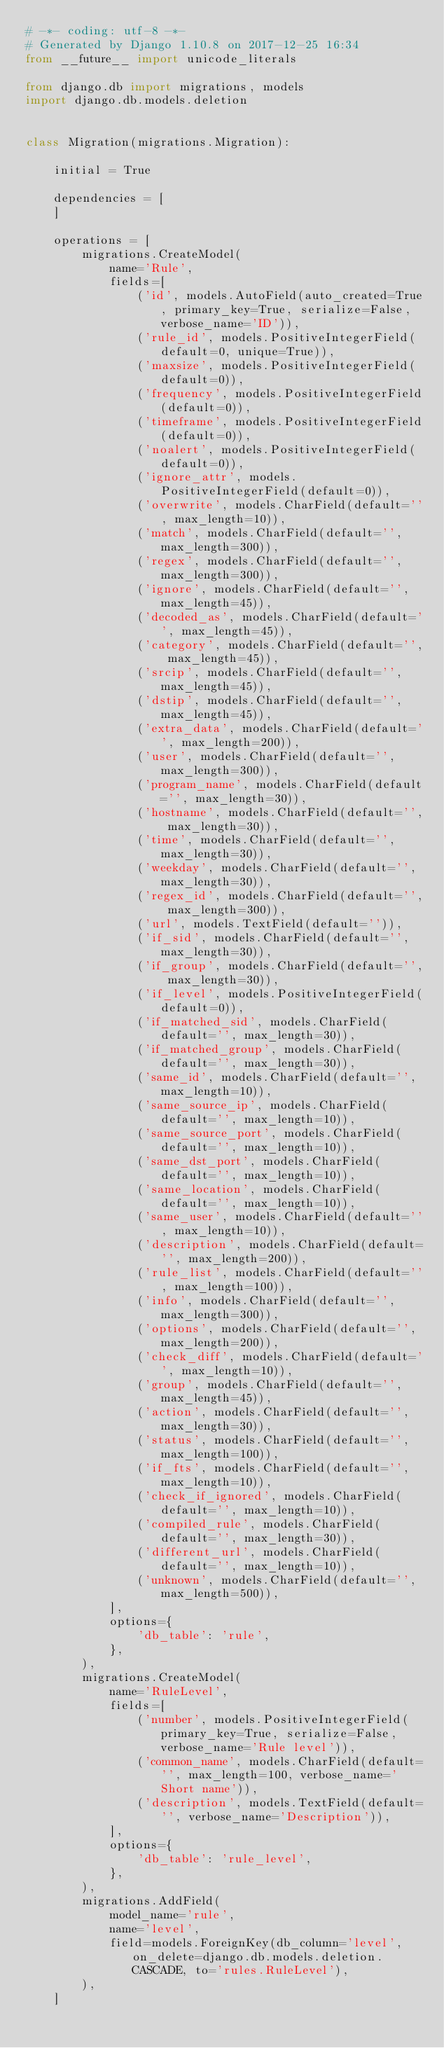Convert code to text. <code><loc_0><loc_0><loc_500><loc_500><_Python_># -*- coding: utf-8 -*-
# Generated by Django 1.10.8 on 2017-12-25 16:34
from __future__ import unicode_literals

from django.db import migrations, models
import django.db.models.deletion


class Migration(migrations.Migration):

    initial = True

    dependencies = [
    ]

    operations = [
        migrations.CreateModel(
            name='Rule',
            fields=[
                ('id', models.AutoField(auto_created=True, primary_key=True, serialize=False, verbose_name='ID')),
                ('rule_id', models.PositiveIntegerField(default=0, unique=True)),
                ('maxsize', models.PositiveIntegerField(default=0)),
                ('frequency', models.PositiveIntegerField(default=0)),
                ('timeframe', models.PositiveIntegerField(default=0)),
                ('noalert', models.PositiveIntegerField(default=0)),
                ('ignore_attr', models.PositiveIntegerField(default=0)),
                ('overwrite', models.CharField(default='', max_length=10)),
                ('match', models.CharField(default='', max_length=300)),
                ('regex', models.CharField(default='', max_length=300)),
                ('ignore', models.CharField(default='', max_length=45)),
                ('decoded_as', models.CharField(default='', max_length=45)),
                ('category', models.CharField(default='', max_length=45)),
                ('srcip', models.CharField(default='', max_length=45)),
                ('dstip', models.CharField(default='', max_length=45)),
                ('extra_data', models.CharField(default='', max_length=200)),
                ('user', models.CharField(default='', max_length=300)),
                ('program_name', models.CharField(default='', max_length=30)),
                ('hostname', models.CharField(default='', max_length=30)),
                ('time', models.CharField(default='', max_length=30)),
                ('weekday', models.CharField(default='', max_length=30)),
                ('regex_id', models.CharField(default='', max_length=300)),
                ('url', models.TextField(default='')),
                ('if_sid', models.CharField(default='', max_length=30)),
                ('if_group', models.CharField(default='', max_length=30)),
                ('if_level', models.PositiveIntegerField(default=0)),
                ('if_matched_sid', models.CharField(default='', max_length=30)),
                ('if_matched_group', models.CharField(default='', max_length=30)),
                ('same_id', models.CharField(default='', max_length=10)),
                ('same_source_ip', models.CharField(default='', max_length=10)),
                ('same_source_port', models.CharField(default='', max_length=10)),
                ('same_dst_port', models.CharField(default='', max_length=10)),
                ('same_location', models.CharField(default='', max_length=10)),
                ('same_user', models.CharField(default='', max_length=10)),
                ('description', models.CharField(default='', max_length=200)),
                ('rule_list', models.CharField(default='', max_length=100)),
                ('info', models.CharField(default='', max_length=300)),
                ('options', models.CharField(default='', max_length=200)),
                ('check_diff', models.CharField(default='', max_length=10)),
                ('group', models.CharField(default='', max_length=45)),
                ('action', models.CharField(default='', max_length=30)),
                ('status', models.CharField(default='', max_length=100)),
                ('if_fts', models.CharField(default='', max_length=10)),
                ('check_if_ignored', models.CharField(default='', max_length=10)),
                ('compiled_rule', models.CharField(default='', max_length=30)),
                ('different_url', models.CharField(default='', max_length=10)),
                ('unknown', models.CharField(default='', max_length=500)),
            ],
            options={
                'db_table': 'rule',
            },
        ),
        migrations.CreateModel(
            name='RuleLevel',
            fields=[
                ('number', models.PositiveIntegerField(primary_key=True, serialize=False, verbose_name='Rule level')),
                ('common_name', models.CharField(default='', max_length=100, verbose_name='Short name')),
                ('description', models.TextField(default='', verbose_name='Description')),
            ],
            options={
                'db_table': 'rule_level',
            },
        ),
        migrations.AddField(
            model_name='rule',
            name='level',
            field=models.ForeignKey(db_column='level', on_delete=django.db.models.deletion.CASCADE, to='rules.RuleLevel'),
        ),
    ]
</code> 